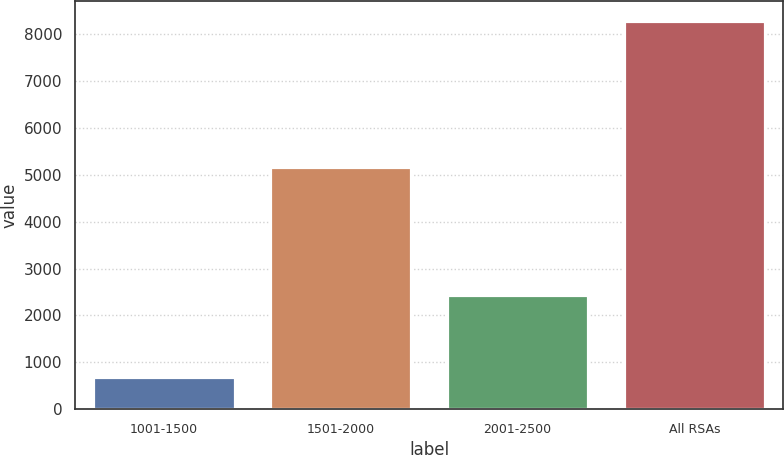<chart> <loc_0><loc_0><loc_500><loc_500><bar_chart><fcel>1001-1500<fcel>1501-2000<fcel>2001-2500<fcel>All RSAs<nl><fcel>690<fcel>5153<fcel>2438<fcel>8281<nl></chart> 